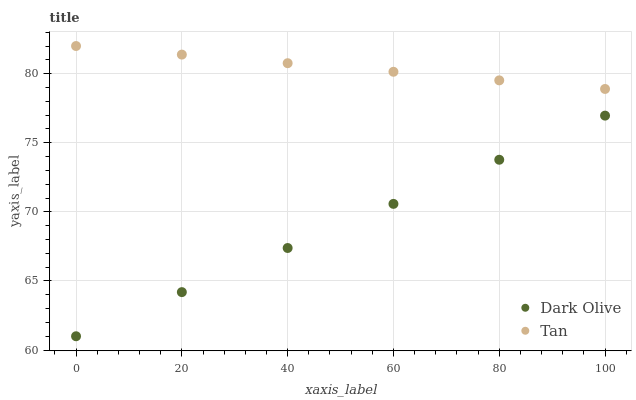Does Dark Olive have the minimum area under the curve?
Answer yes or no. Yes. Does Tan have the maximum area under the curve?
Answer yes or no. Yes. Does Dark Olive have the maximum area under the curve?
Answer yes or no. No. Is Tan the smoothest?
Answer yes or no. Yes. Is Dark Olive the roughest?
Answer yes or no. Yes. Is Dark Olive the smoothest?
Answer yes or no. No. Does Dark Olive have the lowest value?
Answer yes or no. Yes. Does Tan have the highest value?
Answer yes or no. Yes. Does Dark Olive have the highest value?
Answer yes or no. No. Is Dark Olive less than Tan?
Answer yes or no. Yes. Is Tan greater than Dark Olive?
Answer yes or no. Yes. Does Dark Olive intersect Tan?
Answer yes or no. No. 